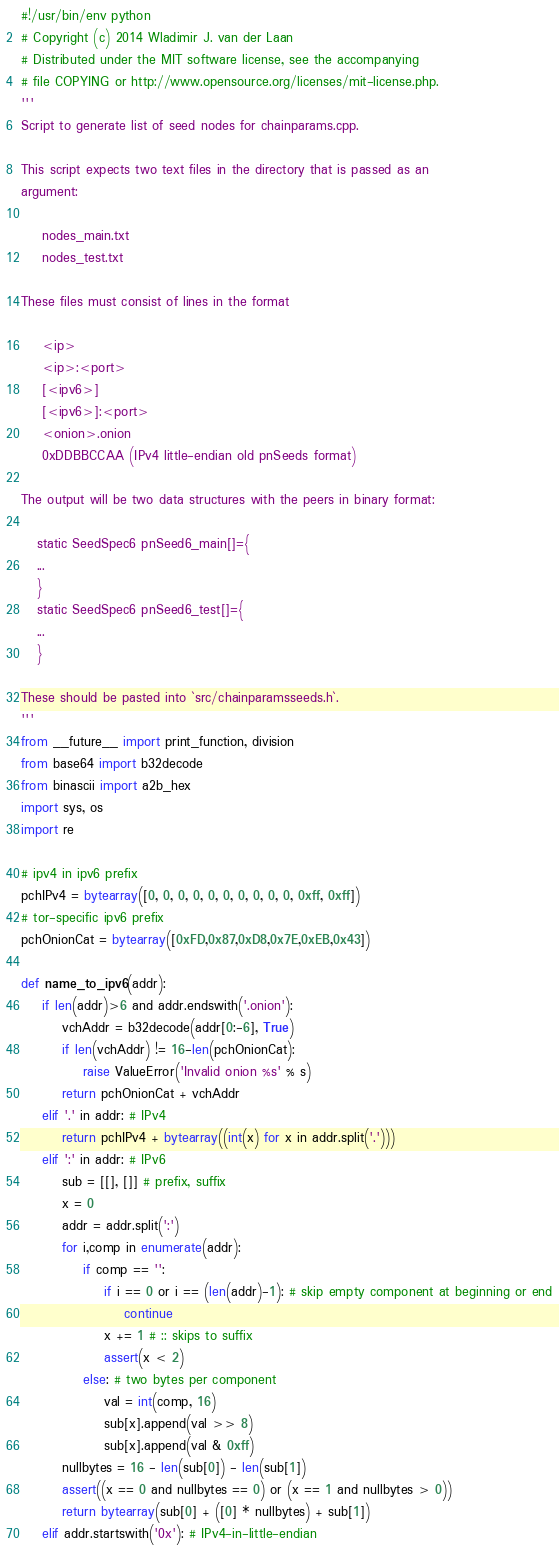<code> <loc_0><loc_0><loc_500><loc_500><_Python_>#!/usr/bin/env python
# Copyright (c) 2014 Wladimir J. van der Laan
# Distributed under the MIT software license, see the accompanying
# file COPYING or http://www.opensource.org/licenses/mit-license.php.
'''
Script to generate list of seed nodes for chainparams.cpp.

This script expects two text files in the directory that is passed as an
argument:

    nodes_main.txt
    nodes_test.txt

These files must consist of lines in the format 

    <ip>
    <ip>:<port>
    [<ipv6>]
    [<ipv6>]:<port>
    <onion>.onion
    0xDDBBCCAA (IPv4 little-endian old pnSeeds format)

The output will be two data structures with the peers in binary format:

   static SeedSpec6 pnSeed6_main[]={
   ...
   }
   static SeedSpec6 pnSeed6_test[]={
   ...
   }

These should be pasted into `src/chainparamsseeds.h`.
'''
from __future__ import print_function, division
from base64 import b32decode
from binascii import a2b_hex
import sys, os
import re

# ipv4 in ipv6 prefix
pchIPv4 = bytearray([0, 0, 0, 0, 0, 0, 0, 0, 0, 0, 0xff, 0xff])
# tor-specific ipv6 prefix
pchOnionCat = bytearray([0xFD,0x87,0xD8,0x7E,0xEB,0x43])

def name_to_ipv6(addr):
    if len(addr)>6 and addr.endswith('.onion'):
        vchAddr = b32decode(addr[0:-6], True)
        if len(vchAddr) != 16-len(pchOnionCat):
            raise ValueError('Invalid onion %s' % s)
        return pchOnionCat + vchAddr
    elif '.' in addr: # IPv4
        return pchIPv4 + bytearray((int(x) for x in addr.split('.')))
    elif ':' in addr: # IPv6
        sub = [[], []] # prefix, suffix
        x = 0
        addr = addr.split(':')
        for i,comp in enumerate(addr):
            if comp == '':
                if i == 0 or i == (len(addr)-1): # skip empty component at beginning or end
                    continue
                x += 1 # :: skips to suffix
                assert(x < 2)
            else: # two bytes per component
                val = int(comp, 16)
                sub[x].append(val >> 8)
                sub[x].append(val & 0xff)
        nullbytes = 16 - len(sub[0]) - len(sub[1])
        assert((x == 0 and nullbytes == 0) or (x == 1 and nullbytes > 0))
        return bytearray(sub[0] + ([0] * nullbytes) + sub[1])
    elif addr.startswith('0x'): # IPv4-in-little-endian</code> 